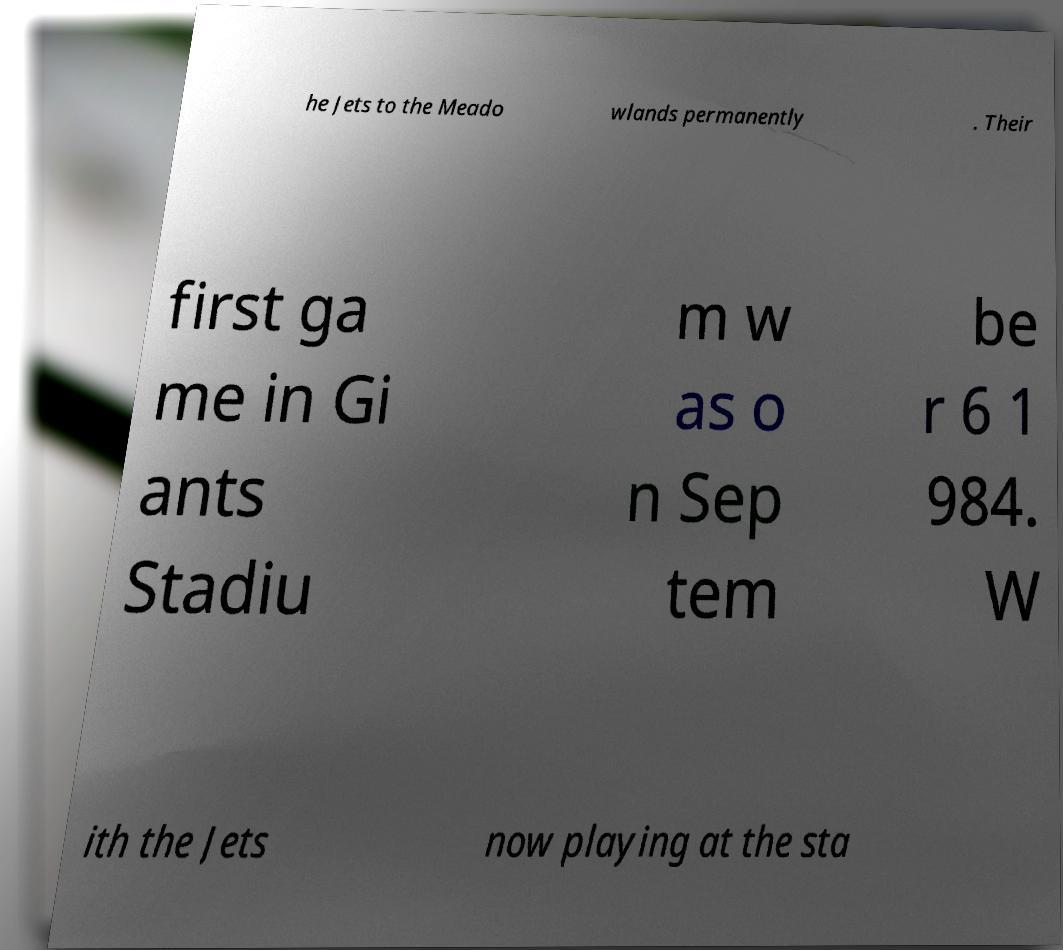I need the written content from this picture converted into text. Can you do that? he Jets to the Meado wlands permanently . Their first ga me in Gi ants Stadiu m w as o n Sep tem be r 6 1 984. W ith the Jets now playing at the sta 